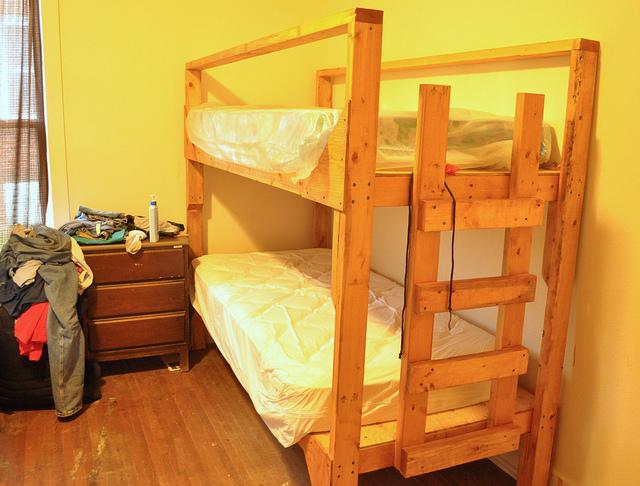What are these beds called?
Answer briefly. Bunk beds. Are there sheets on the beds?
Be succinct. No. What color are the walls?
Give a very brief answer. Yellow. 